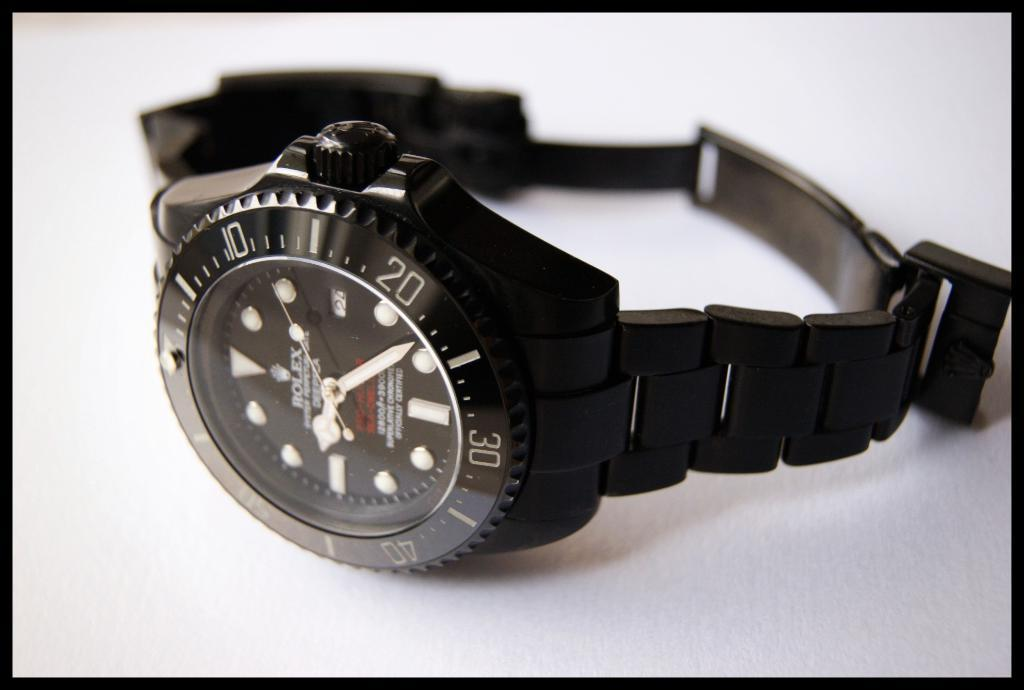<image>
Render a clear and concise summary of the photo. Rolex watch that says the time, which is 9:22. 